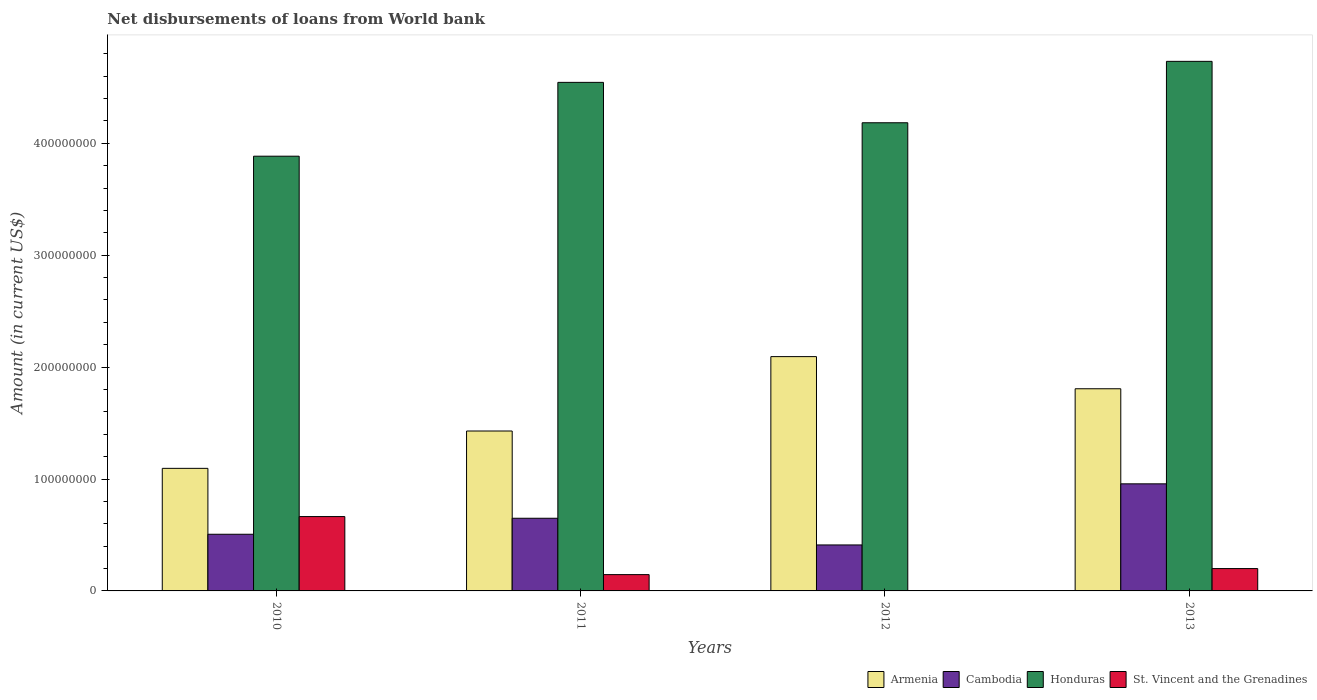How many different coloured bars are there?
Offer a very short reply. 4. Are the number of bars per tick equal to the number of legend labels?
Make the answer very short. No. Are the number of bars on each tick of the X-axis equal?
Offer a very short reply. No. How many bars are there on the 3rd tick from the left?
Give a very brief answer. 3. How many bars are there on the 4th tick from the right?
Give a very brief answer. 4. What is the label of the 2nd group of bars from the left?
Provide a short and direct response. 2011. What is the amount of loan disbursed from World Bank in Honduras in 2011?
Make the answer very short. 4.54e+08. Across all years, what is the maximum amount of loan disbursed from World Bank in Armenia?
Keep it short and to the point. 2.09e+08. Across all years, what is the minimum amount of loan disbursed from World Bank in Armenia?
Your response must be concise. 1.10e+08. In which year was the amount of loan disbursed from World Bank in Armenia maximum?
Offer a very short reply. 2012. What is the total amount of loan disbursed from World Bank in St. Vincent and the Grenadines in the graph?
Offer a very short reply. 1.01e+08. What is the difference between the amount of loan disbursed from World Bank in Honduras in 2010 and that in 2011?
Your answer should be compact. -6.60e+07. What is the difference between the amount of loan disbursed from World Bank in Cambodia in 2010 and the amount of loan disbursed from World Bank in Honduras in 2013?
Your response must be concise. -4.23e+08. What is the average amount of loan disbursed from World Bank in Cambodia per year?
Keep it short and to the point. 6.31e+07. In the year 2010, what is the difference between the amount of loan disbursed from World Bank in Cambodia and amount of loan disbursed from World Bank in Honduras?
Give a very brief answer. -3.38e+08. In how many years, is the amount of loan disbursed from World Bank in Cambodia greater than 380000000 US$?
Provide a short and direct response. 0. What is the ratio of the amount of loan disbursed from World Bank in Honduras in 2011 to that in 2013?
Your answer should be compact. 0.96. Is the amount of loan disbursed from World Bank in Cambodia in 2010 less than that in 2011?
Ensure brevity in your answer.  Yes. What is the difference between the highest and the second highest amount of loan disbursed from World Bank in St. Vincent and the Grenadines?
Your response must be concise. 4.65e+07. What is the difference between the highest and the lowest amount of loan disbursed from World Bank in Honduras?
Your answer should be compact. 8.47e+07. In how many years, is the amount of loan disbursed from World Bank in Cambodia greater than the average amount of loan disbursed from World Bank in Cambodia taken over all years?
Provide a short and direct response. 2. Is the sum of the amount of loan disbursed from World Bank in Cambodia in 2011 and 2013 greater than the maximum amount of loan disbursed from World Bank in Armenia across all years?
Your answer should be very brief. No. Is it the case that in every year, the sum of the amount of loan disbursed from World Bank in Armenia and amount of loan disbursed from World Bank in Cambodia is greater than the sum of amount of loan disbursed from World Bank in St. Vincent and the Grenadines and amount of loan disbursed from World Bank in Honduras?
Ensure brevity in your answer.  No. Is it the case that in every year, the sum of the amount of loan disbursed from World Bank in Cambodia and amount of loan disbursed from World Bank in Armenia is greater than the amount of loan disbursed from World Bank in Honduras?
Give a very brief answer. No. Are all the bars in the graph horizontal?
Keep it short and to the point. No. Where does the legend appear in the graph?
Provide a short and direct response. Bottom right. How many legend labels are there?
Your response must be concise. 4. What is the title of the graph?
Your response must be concise. Net disbursements of loans from World bank. What is the Amount (in current US$) of Armenia in 2010?
Your answer should be compact. 1.10e+08. What is the Amount (in current US$) in Cambodia in 2010?
Offer a very short reply. 5.06e+07. What is the Amount (in current US$) in Honduras in 2010?
Offer a terse response. 3.88e+08. What is the Amount (in current US$) in St. Vincent and the Grenadines in 2010?
Provide a succinct answer. 6.64e+07. What is the Amount (in current US$) in Armenia in 2011?
Your answer should be compact. 1.43e+08. What is the Amount (in current US$) of Cambodia in 2011?
Your response must be concise. 6.49e+07. What is the Amount (in current US$) in Honduras in 2011?
Your response must be concise. 4.54e+08. What is the Amount (in current US$) of St. Vincent and the Grenadines in 2011?
Offer a very short reply. 1.46e+07. What is the Amount (in current US$) in Armenia in 2012?
Provide a short and direct response. 2.09e+08. What is the Amount (in current US$) of Cambodia in 2012?
Give a very brief answer. 4.11e+07. What is the Amount (in current US$) in Honduras in 2012?
Your response must be concise. 4.18e+08. What is the Amount (in current US$) in St. Vincent and the Grenadines in 2012?
Offer a terse response. 0. What is the Amount (in current US$) of Armenia in 2013?
Your response must be concise. 1.81e+08. What is the Amount (in current US$) of Cambodia in 2013?
Your answer should be compact. 9.57e+07. What is the Amount (in current US$) of Honduras in 2013?
Ensure brevity in your answer.  4.73e+08. What is the Amount (in current US$) of St. Vincent and the Grenadines in 2013?
Ensure brevity in your answer.  2.00e+07. Across all years, what is the maximum Amount (in current US$) of Armenia?
Provide a succinct answer. 2.09e+08. Across all years, what is the maximum Amount (in current US$) in Cambodia?
Provide a succinct answer. 9.57e+07. Across all years, what is the maximum Amount (in current US$) of Honduras?
Offer a very short reply. 4.73e+08. Across all years, what is the maximum Amount (in current US$) of St. Vincent and the Grenadines?
Give a very brief answer. 6.64e+07. Across all years, what is the minimum Amount (in current US$) of Armenia?
Provide a short and direct response. 1.10e+08. Across all years, what is the minimum Amount (in current US$) in Cambodia?
Make the answer very short. 4.11e+07. Across all years, what is the minimum Amount (in current US$) of Honduras?
Offer a terse response. 3.88e+08. Across all years, what is the minimum Amount (in current US$) of St. Vincent and the Grenadines?
Offer a very short reply. 0. What is the total Amount (in current US$) in Armenia in the graph?
Your answer should be very brief. 6.42e+08. What is the total Amount (in current US$) of Cambodia in the graph?
Keep it short and to the point. 2.52e+08. What is the total Amount (in current US$) of Honduras in the graph?
Keep it short and to the point. 1.73e+09. What is the total Amount (in current US$) in St. Vincent and the Grenadines in the graph?
Offer a terse response. 1.01e+08. What is the difference between the Amount (in current US$) of Armenia in 2010 and that in 2011?
Provide a succinct answer. -3.34e+07. What is the difference between the Amount (in current US$) of Cambodia in 2010 and that in 2011?
Your answer should be compact. -1.43e+07. What is the difference between the Amount (in current US$) of Honduras in 2010 and that in 2011?
Your answer should be very brief. -6.60e+07. What is the difference between the Amount (in current US$) in St. Vincent and the Grenadines in 2010 and that in 2011?
Your answer should be compact. 5.19e+07. What is the difference between the Amount (in current US$) in Armenia in 2010 and that in 2012?
Make the answer very short. -9.98e+07. What is the difference between the Amount (in current US$) of Cambodia in 2010 and that in 2012?
Give a very brief answer. 9.54e+06. What is the difference between the Amount (in current US$) of Honduras in 2010 and that in 2012?
Ensure brevity in your answer.  -2.99e+07. What is the difference between the Amount (in current US$) of Armenia in 2010 and that in 2013?
Your answer should be compact. -7.11e+07. What is the difference between the Amount (in current US$) in Cambodia in 2010 and that in 2013?
Keep it short and to the point. -4.51e+07. What is the difference between the Amount (in current US$) of Honduras in 2010 and that in 2013?
Make the answer very short. -8.47e+07. What is the difference between the Amount (in current US$) in St. Vincent and the Grenadines in 2010 and that in 2013?
Your answer should be compact. 4.65e+07. What is the difference between the Amount (in current US$) of Armenia in 2011 and that in 2012?
Offer a terse response. -6.65e+07. What is the difference between the Amount (in current US$) of Cambodia in 2011 and that in 2012?
Provide a short and direct response. 2.38e+07. What is the difference between the Amount (in current US$) of Honduras in 2011 and that in 2012?
Offer a very short reply. 3.61e+07. What is the difference between the Amount (in current US$) in Armenia in 2011 and that in 2013?
Make the answer very short. -3.77e+07. What is the difference between the Amount (in current US$) of Cambodia in 2011 and that in 2013?
Give a very brief answer. -3.08e+07. What is the difference between the Amount (in current US$) in Honduras in 2011 and that in 2013?
Your answer should be very brief. -1.88e+07. What is the difference between the Amount (in current US$) in St. Vincent and the Grenadines in 2011 and that in 2013?
Offer a very short reply. -5.41e+06. What is the difference between the Amount (in current US$) of Armenia in 2012 and that in 2013?
Offer a very short reply. 2.87e+07. What is the difference between the Amount (in current US$) of Cambodia in 2012 and that in 2013?
Provide a short and direct response. -5.46e+07. What is the difference between the Amount (in current US$) in Honduras in 2012 and that in 2013?
Give a very brief answer. -5.49e+07. What is the difference between the Amount (in current US$) of Armenia in 2010 and the Amount (in current US$) of Cambodia in 2011?
Offer a terse response. 4.46e+07. What is the difference between the Amount (in current US$) in Armenia in 2010 and the Amount (in current US$) in Honduras in 2011?
Give a very brief answer. -3.45e+08. What is the difference between the Amount (in current US$) of Armenia in 2010 and the Amount (in current US$) of St. Vincent and the Grenadines in 2011?
Provide a succinct answer. 9.50e+07. What is the difference between the Amount (in current US$) of Cambodia in 2010 and the Amount (in current US$) of Honduras in 2011?
Your answer should be very brief. -4.04e+08. What is the difference between the Amount (in current US$) of Cambodia in 2010 and the Amount (in current US$) of St. Vincent and the Grenadines in 2011?
Your answer should be compact. 3.61e+07. What is the difference between the Amount (in current US$) of Honduras in 2010 and the Amount (in current US$) of St. Vincent and the Grenadines in 2011?
Keep it short and to the point. 3.74e+08. What is the difference between the Amount (in current US$) in Armenia in 2010 and the Amount (in current US$) in Cambodia in 2012?
Offer a very short reply. 6.84e+07. What is the difference between the Amount (in current US$) of Armenia in 2010 and the Amount (in current US$) of Honduras in 2012?
Give a very brief answer. -3.09e+08. What is the difference between the Amount (in current US$) of Cambodia in 2010 and the Amount (in current US$) of Honduras in 2012?
Your answer should be very brief. -3.68e+08. What is the difference between the Amount (in current US$) in Armenia in 2010 and the Amount (in current US$) in Cambodia in 2013?
Give a very brief answer. 1.38e+07. What is the difference between the Amount (in current US$) of Armenia in 2010 and the Amount (in current US$) of Honduras in 2013?
Your response must be concise. -3.64e+08. What is the difference between the Amount (in current US$) in Armenia in 2010 and the Amount (in current US$) in St. Vincent and the Grenadines in 2013?
Your answer should be very brief. 8.96e+07. What is the difference between the Amount (in current US$) of Cambodia in 2010 and the Amount (in current US$) of Honduras in 2013?
Provide a succinct answer. -4.23e+08. What is the difference between the Amount (in current US$) in Cambodia in 2010 and the Amount (in current US$) in St. Vincent and the Grenadines in 2013?
Provide a succinct answer. 3.07e+07. What is the difference between the Amount (in current US$) of Honduras in 2010 and the Amount (in current US$) of St. Vincent and the Grenadines in 2013?
Offer a very short reply. 3.68e+08. What is the difference between the Amount (in current US$) in Armenia in 2011 and the Amount (in current US$) in Cambodia in 2012?
Your answer should be compact. 1.02e+08. What is the difference between the Amount (in current US$) in Armenia in 2011 and the Amount (in current US$) in Honduras in 2012?
Offer a terse response. -2.75e+08. What is the difference between the Amount (in current US$) in Cambodia in 2011 and the Amount (in current US$) in Honduras in 2012?
Give a very brief answer. -3.53e+08. What is the difference between the Amount (in current US$) of Armenia in 2011 and the Amount (in current US$) of Cambodia in 2013?
Provide a succinct answer. 4.72e+07. What is the difference between the Amount (in current US$) in Armenia in 2011 and the Amount (in current US$) in Honduras in 2013?
Make the answer very short. -3.30e+08. What is the difference between the Amount (in current US$) in Armenia in 2011 and the Amount (in current US$) in St. Vincent and the Grenadines in 2013?
Provide a succinct answer. 1.23e+08. What is the difference between the Amount (in current US$) in Cambodia in 2011 and the Amount (in current US$) in Honduras in 2013?
Provide a succinct answer. -4.08e+08. What is the difference between the Amount (in current US$) of Cambodia in 2011 and the Amount (in current US$) of St. Vincent and the Grenadines in 2013?
Provide a short and direct response. 4.50e+07. What is the difference between the Amount (in current US$) of Honduras in 2011 and the Amount (in current US$) of St. Vincent and the Grenadines in 2013?
Provide a short and direct response. 4.34e+08. What is the difference between the Amount (in current US$) in Armenia in 2012 and the Amount (in current US$) in Cambodia in 2013?
Your answer should be compact. 1.14e+08. What is the difference between the Amount (in current US$) in Armenia in 2012 and the Amount (in current US$) in Honduras in 2013?
Make the answer very short. -2.64e+08. What is the difference between the Amount (in current US$) in Armenia in 2012 and the Amount (in current US$) in St. Vincent and the Grenadines in 2013?
Give a very brief answer. 1.89e+08. What is the difference between the Amount (in current US$) of Cambodia in 2012 and the Amount (in current US$) of Honduras in 2013?
Your answer should be compact. -4.32e+08. What is the difference between the Amount (in current US$) of Cambodia in 2012 and the Amount (in current US$) of St. Vincent and the Grenadines in 2013?
Ensure brevity in your answer.  2.11e+07. What is the difference between the Amount (in current US$) in Honduras in 2012 and the Amount (in current US$) in St. Vincent and the Grenadines in 2013?
Offer a very short reply. 3.98e+08. What is the average Amount (in current US$) of Armenia per year?
Your answer should be very brief. 1.61e+08. What is the average Amount (in current US$) in Cambodia per year?
Offer a very short reply. 6.31e+07. What is the average Amount (in current US$) in Honduras per year?
Give a very brief answer. 4.34e+08. What is the average Amount (in current US$) in St. Vincent and the Grenadines per year?
Ensure brevity in your answer.  2.52e+07. In the year 2010, what is the difference between the Amount (in current US$) in Armenia and Amount (in current US$) in Cambodia?
Make the answer very short. 5.89e+07. In the year 2010, what is the difference between the Amount (in current US$) in Armenia and Amount (in current US$) in Honduras?
Offer a terse response. -2.79e+08. In the year 2010, what is the difference between the Amount (in current US$) in Armenia and Amount (in current US$) in St. Vincent and the Grenadines?
Your answer should be very brief. 4.31e+07. In the year 2010, what is the difference between the Amount (in current US$) of Cambodia and Amount (in current US$) of Honduras?
Keep it short and to the point. -3.38e+08. In the year 2010, what is the difference between the Amount (in current US$) of Cambodia and Amount (in current US$) of St. Vincent and the Grenadines?
Your answer should be very brief. -1.58e+07. In the year 2010, what is the difference between the Amount (in current US$) in Honduras and Amount (in current US$) in St. Vincent and the Grenadines?
Your response must be concise. 3.22e+08. In the year 2011, what is the difference between the Amount (in current US$) in Armenia and Amount (in current US$) in Cambodia?
Give a very brief answer. 7.80e+07. In the year 2011, what is the difference between the Amount (in current US$) in Armenia and Amount (in current US$) in Honduras?
Offer a terse response. -3.12e+08. In the year 2011, what is the difference between the Amount (in current US$) of Armenia and Amount (in current US$) of St. Vincent and the Grenadines?
Keep it short and to the point. 1.28e+08. In the year 2011, what is the difference between the Amount (in current US$) of Cambodia and Amount (in current US$) of Honduras?
Ensure brevity in your answer.  -3.89e+08. In the year 2011, what is the difference between the Amount (in current US$) in Cambodia and Amount (in current US$) in St. Vincent and the Grenadines?
Your answer should be very brief. 5.04e+07. In the year 2011, what is the difference between the Amount (in current US$) in Honduras and Amount (in current US$) in St. Vincent and the Grenadines?
Provide a short and direct response. 4.40e+08. In the year 2012, what is the difference between the Amount (in current US$) in Armenia and Amount (in current US$) in Cambodia?
Ensure brevity in your answer.  1.68e+08. In the year 2012, what is the difference between the Amount (in current US$) in Armenia and Amount (in current US$) in Honduras?
Your answer should be compact. -2.09e+08. In the year 2012, what is the difference between the Amount (in current US$) of Cambodia and Amount (in current US$) of Honduras?
Make the answer very short. -3.77e+08. In the year 2013, what is the difference between the Amount (in current US$) in Armenia and Amount (in current US$) in Cambodia?
Offer a terse response. 8.50e+07. In the year 2013, what is the difference between the Amount (in current US$) of Armenia and Amount (in current US$) of Honduras?
Ensure brevity in your answer.  -2.93e+08. In the year 2013, what is the difference between the Amount (in current US$) in Armenia and Amount (in current US$) in St. Vincent and the Grenadines?
Provide a succinct answer. 1.61e+08. In the year 2013, what is the difference between the Amount (in current US$) in Cambodia and Amount (in current US$) in Honduras?
Offer a terse response. -3.78e+08. In the year 2013, what is the difference between the Amount (in current US$) of Cambodia and Amount (in current US$) of St. Vincent and the Grenadines?
Your answer should be very brief. 7.57e+07. In the year 2013, what is the difference between the Amount (in current US$) of Honduras and Amount (in current US$) of St. Vincent and the Grenadines?
Your response must be concise. 4.53e+08. What is the ratio of the Amount (in current US$) in Armenia in 2010 to that in 2011?
Ensure brevity in your answer.  0.77. What is the ratio of the Amount (in current US$) of Cambodia in 2010 to that in 2011?
Your answer should be very brief. 0.78. What is the ratio of the Amount (in current US$) of Honduras in 2010 to that in 2011?
Ensure brevity in your answer.  0.85. What is the ratio of the Amount (in current US$) in St. Vincent and the Grenadines in 2010 to that in 2011?
Provide a succinct answer. 4.56. What is the ratio of the Amount (in current US$) in Armenia in 2010 to that in 2012?
Ensure brevity in your answer.  0.52. What is the ratio of the Amount (in current US$) in Cambodia in 2010 to that in 2012?
Provide a short and direct response. 1.23. What is the ratio of the Amount (in current US$) of Armenia in 2010 to that in 2013?
Make the answer very short. 0.61. What is the ratio of the Amount (in current US$) in Cambodia in 2010 to that in 2013?
Provide a short and direct response. 0.53. What is the ratio of the Amount (in current US$) of Honduras in 2010 to that in 2013?
Provide a succinct answer. 0.82. What is the ratio of the Amount (in current US$) in St. Vincent and the Grenadines in 2010 to that in 2013?
Your response must be concise. 3.33. What is the ratio of the Amount (in current US$) in Armenia in 2011 to that in 2012?
Provide a short and direct response. 0.68. What is the ratio of the Amount (in current US$) of Cambodia in 2011 to that in 2012?
Provide a succinct answer. 1.58. What is the ratio of the Amount (in current US$) of Honduras in 2011 to that in 2012?
Ensure brevity in your answer.  1.09. What is the ratio of the Amount (in current US$) of Armenia in 2011 to that in 2013?
Your answer should be compact. 0.79. What is the ratio of the Amount (in current US$) of Cambodia in 2011 to that in 2013?
Offer a very short reply. 0.68. What is the ratio of the Amount (in current US$) in Honduras in 2011 to that in 2013?
Provide a succinct answer. 0.96. What is the ratio of the Amount (in current US$) in St. Vincent and the Grenadines in 2011 to that in 2013?
Provide a succinct answer. 0.73. What is the ratio of the Amount (in current US$) of Armenia in 2012 to that in 2013?
Your answer should be very brief. 1.16. What is the ratio of the Amount (in current US$) in Cambodia in 2012 to that in 2013?
Your response must be concise. 0.43. What is the ratio of the Amount (in current US$) of Honduras in 2012 to that in 2013?
Give a very brief answer. 0.88. What is the difference between the highest and the second highest Amount (in current US$) of Armenia?
Give a very brief answer. 2.87e+07. What is the difference between the highest and the second highest Amount (in current US$) of Cambodia?
Ensure brevity in your answer.  3.08e+07. What is the difference between the highest and the second highest Amount (in current US$) in Honduras?
Offer a terse response. 1.88e+07. What is the difference between the highest and the second highest Amount (in current US$) of St. Vincent and the Grenadines?
Offer a very short reply. 4.65e+07. What is the difference between the highest and the lowest Amount (in current US$) of Armenia?
Provide a short and direct response. 9.98e+07. What is the difference between the highest and the lowest Amount (in current US$) in Cambodia?
Offer a terse response. 5.46e+07. What is the difference between the highest and the lowest Amount (in current US$) in Honduras?
Ensure brevity in your answer.  8.47e+07. What is the difference between the highest and the lowest Amount (in current US$) of St. Vincent and the Grenadines?
Your answer should be very brief. 6.64e+07. 